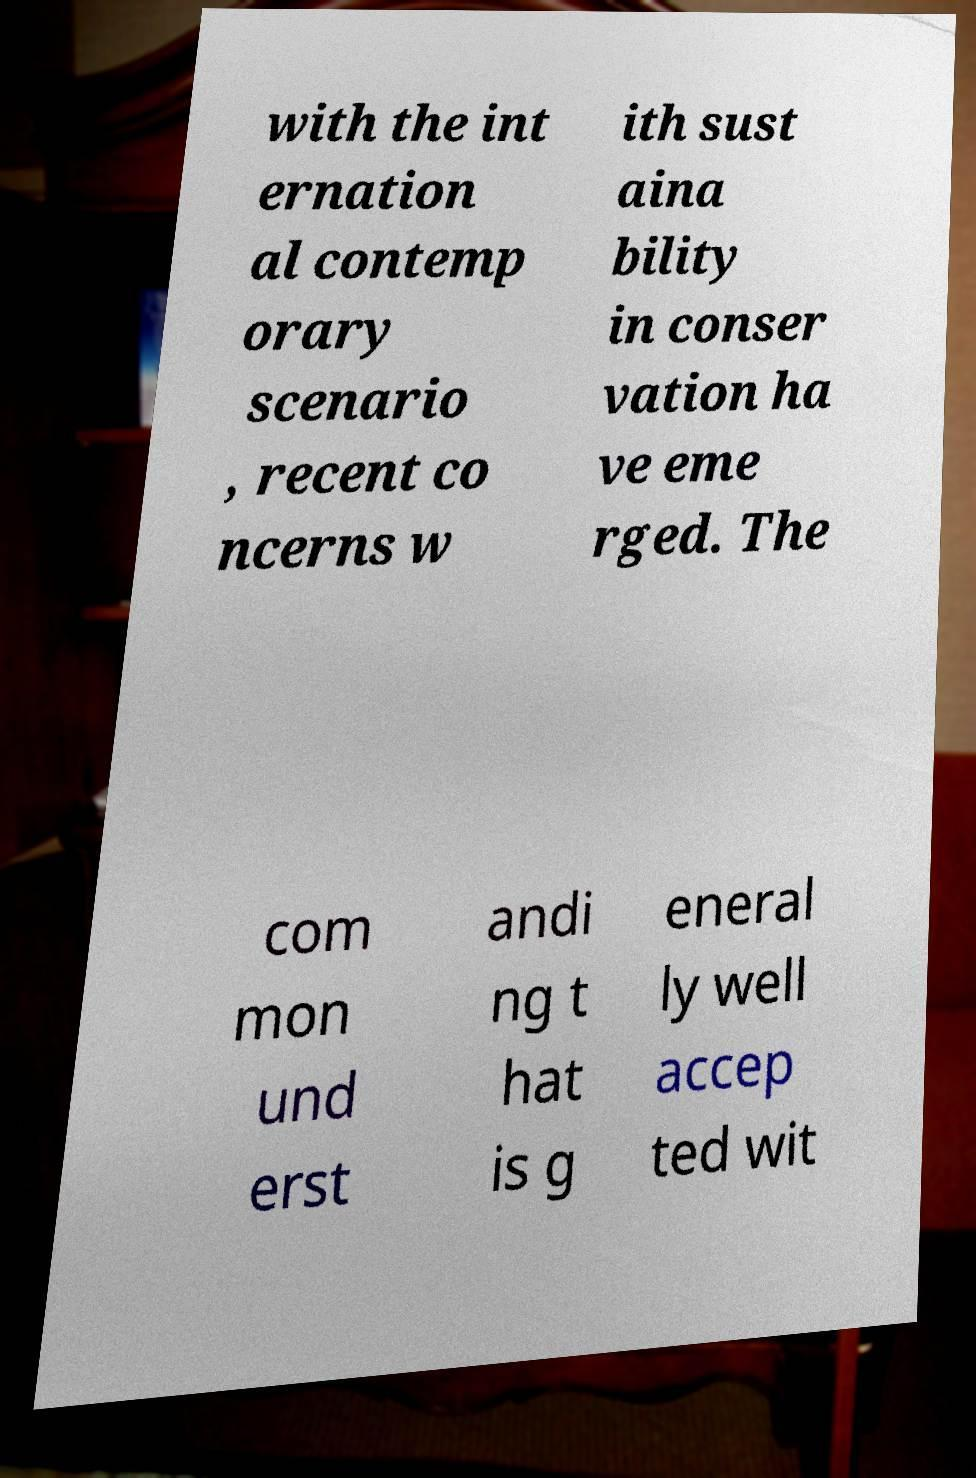Can you accurately transcribe the text from the provided image for me? with the int ernation al contemp orary scenario , recent co ncerns w ith sust aina bility in conser vation ha ve eme rged. The com mon und erst andi ng t hat is g eneral ly well accep ted wit 